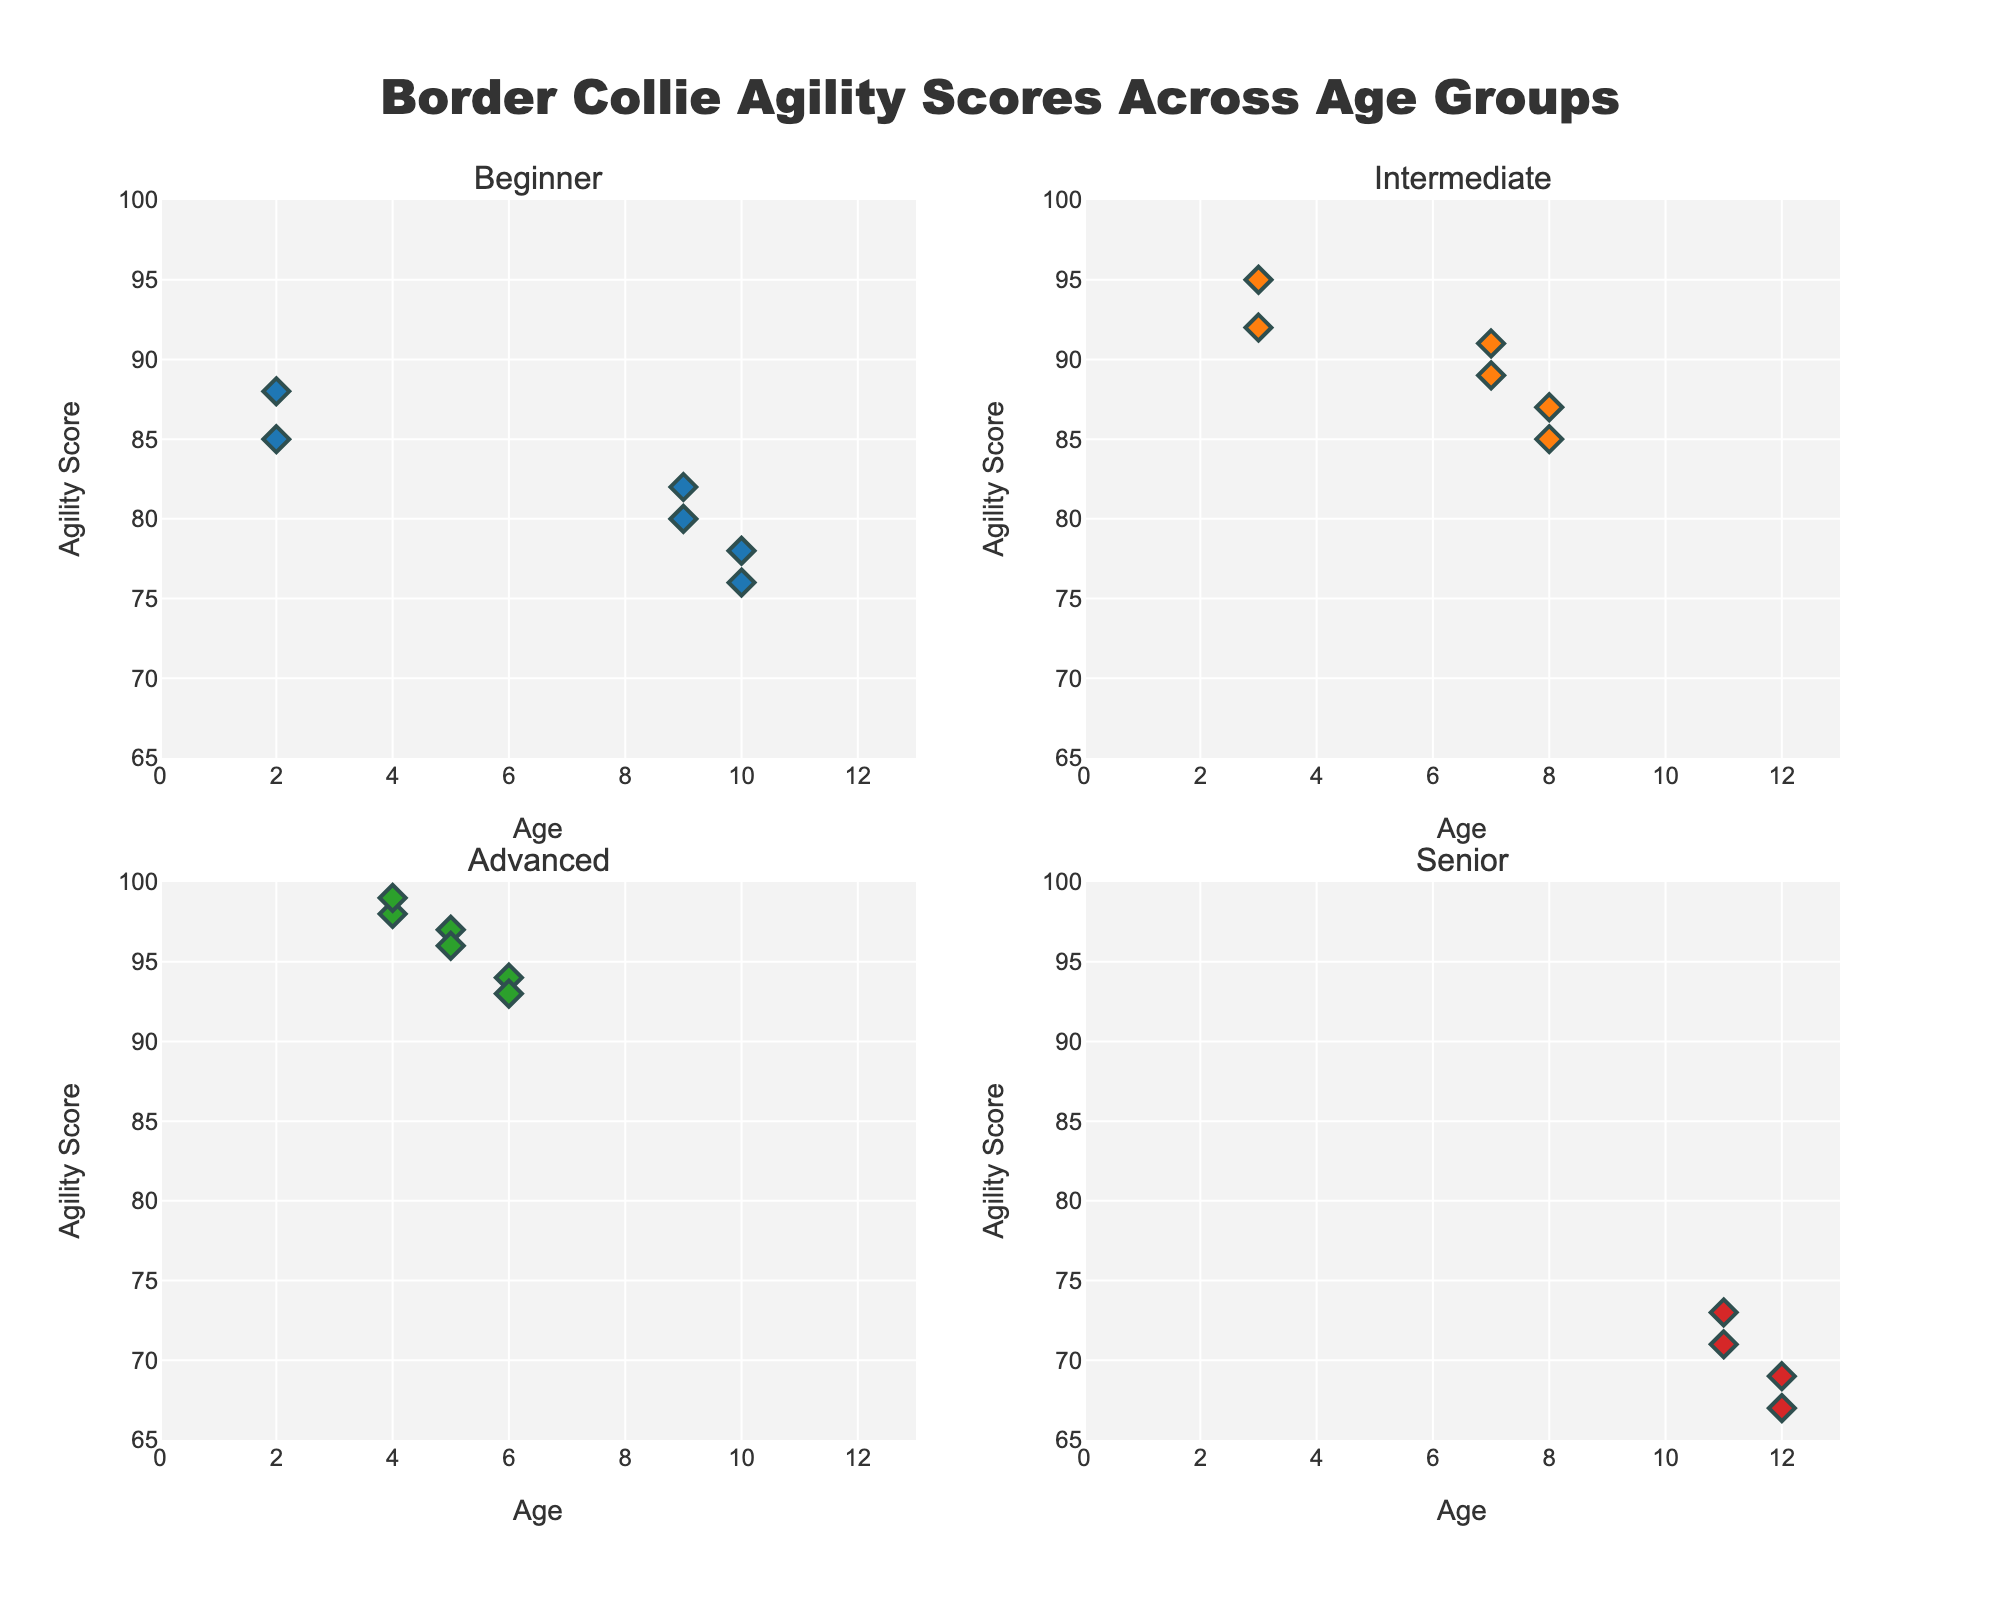What is the title of the plot? The title of the plot is typically found at the top of the figure. In this case, the title text can be read directly from the title element.
Answer: Border Collie Agility Scores Across Age Groups Which age group has the highest agility scores in the 'Advanced' category? By examining the 'Advanced' subplot, we can find the data points with the highest agility scores and see which age group they belong to.
Answer: Age 4 How many data points are shown in the 'Senior' category scatter plot? By counting the individual markers in the 'Senior' category subplot, we can find the number of points.
Answer: 4 Which category has the lowest maximum agility score and what score is it? By comparing the highest scores in each category's subplot, we can identify the category with the lowest maximum score. Compare the points in each subplot.
Answer: Senior, 73 What is the range of agility scores for the 'Intermediate' category? The range can be found by subtracting the lowest agility score from the highest score within the 'Intermediate' subplot. Examine the data points in the 'Intermediate' subplot.
Answer: 85 - 92 What is the difference in the highest agility scores between the 'Beginner' and 'Advanced' categories? Identify the highest scores in each of the 'Beginner' and 'Advanced' subplots and subtract the 'Beginner' score from the 'Advanced' score.
Answer: 15 How do the agility scores change with age in the 'Intermediate' category? Observe the trend of agility scores with increasing age in the 'Intermediate' subplot. Check if the scores increase, decrease, or remain stable.
Answer: Decrease Which age group shows up only in the 'Advanced' category? Look for age markers unique to the 'Advanced' subplot that do not appear in other subplots.
Answer: Age 5 